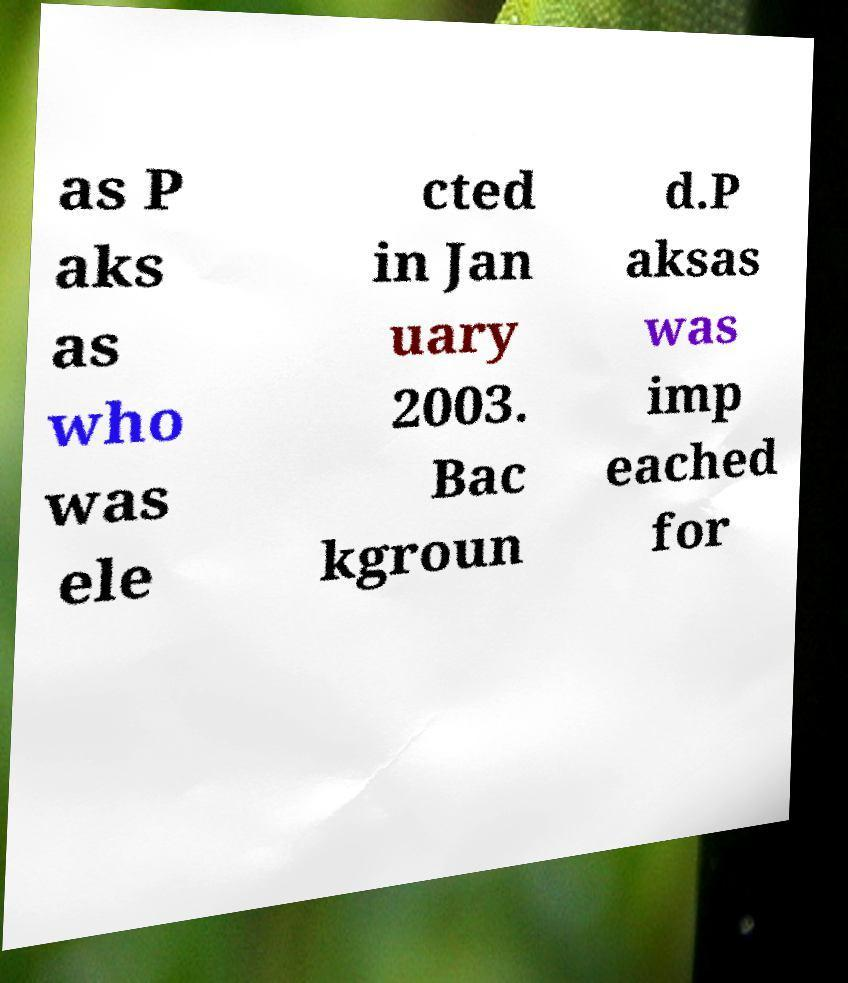Can you accurately transcribe the text from the provided image for me? as P aks as who was ele cted in Jan uary 2003. Bac kgroun d.P aksas was imp eached for 